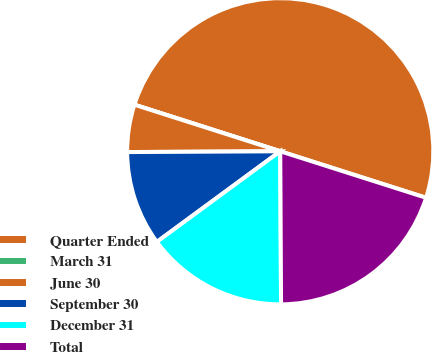<chart> <loc_0><loc_0><loc_500><loc_500><pie_chart><fcel>Quarter Ended<fcel>March 31<fcel>June 30<fcel>September 30<fcel>December 31<fcel>Total<nl><fcel>49.99%<fcel>0.0%<fcel>5.0%<fcel>10.0%<fcel>15.0%<fcel>20.0%<nl></chart> 